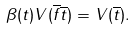<formula> <loc_0><loc_0><loc_500><loc_500>\beta ( t ) V ( \overline { f } \overline { t } ) = V ( \overline { t } ) .</formula> 